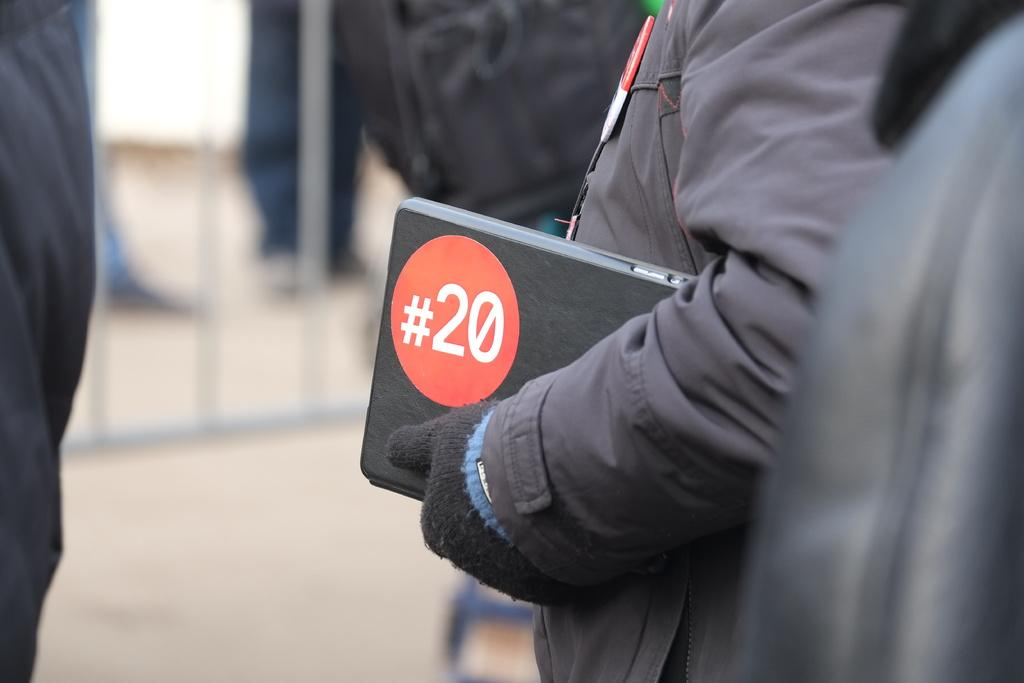How many people are in the image? There is a group of people in the image. Can you describe the person in front of the group? The person in front is wearing a gray jacket and holding a black object. What can be seen in the background of the image? There is railing visible in the background of the image. What type of van is parked next to the group of people in the image? There is no van present in the image. What role does the army play in the image? The image does not depict any army personnel or activities. 